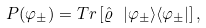Convert formula to latex. <formula><loc_0><loc_0><loc_500><loc_500>P ( \varphi _ { \pm } ) = T r \left [ \hat { \varrho } \ | \varphi _ { \pm } \rangle \langle \varphi _ { \pm } | \right ] ,</formula> 